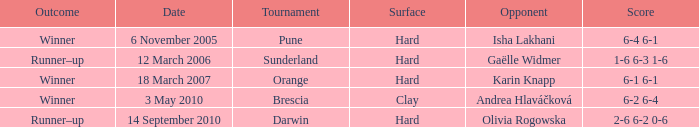On what sort of surface was the pune tournament held? Hard. 